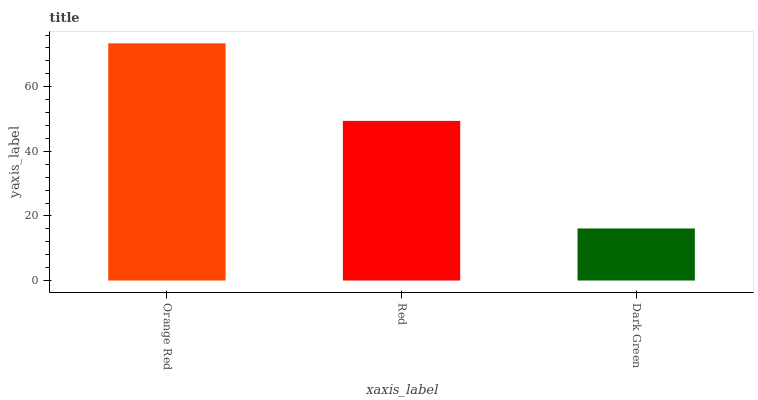Is Red the minimum?
Answer yes or no. No. Is Red the maximum?
Answer yes or no. No. Is Orange Red greater than Red?
Answer yes or no. Yes. Is Red less than Orange Red?
Answer yes or no. Yes. Is Red greater than Orange Red?
Answer yes or no. No. Is Orange Red less than Red?
Answer yes or no. No. Is Red the high median?
Answer yes or no. Yes. Is Red the low median?
Answer yes or no. Yes. Is Dark Green the high median?
Answer yes or no. No. Is Orange Red the low median?
Answer yes or no. No. 